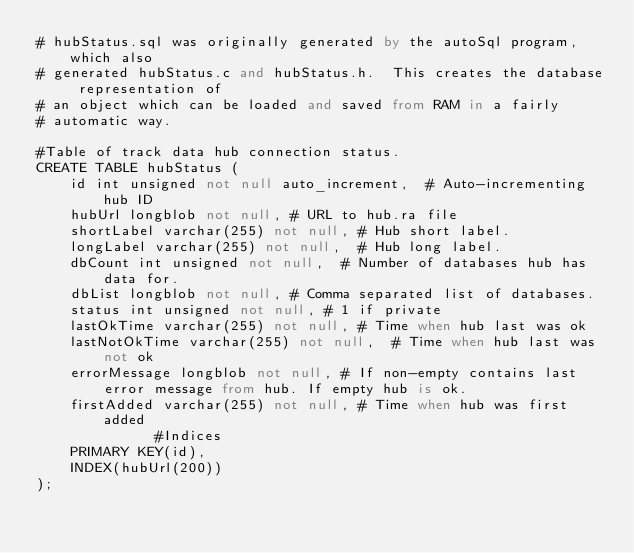<code> <loc_0><loc_0><loc_500><loc_500><_SQL_># hubStatus.sql was originally generated by the autoSql program, which also 
# generated hubStatus.c and hubStatus.h.  This creates the database representation of
# an object which can be loaded and saved from RAM in a fairly 
# automatic way.

#Table of track data hub connection status.
CREATE TABLE hubStatus (
    id int unsigned not null auto_increment,	# Auto-incrementing hub ID
    hubUrl longblob not null,	# URL to hub.ra file
    shortLabel varchar(255) not null,	# Hub short label.
    longLabel varchar(255) not null,	# Hub long label.
    dbCount int unsigned not null,	# Number of databases hub has data for.
    dbList longblob not null,	# Comma separated list of databases.
    status int unsigned not null,	# 1 if private
    lastOkTime varchar(255) not null,	# Time when hub last was ok
    lastNotOkTime varchar(255) not null,	# Time when hub last was not ok
    errorMessage longblob not null,	# If non-empty contains last error message from hub. If empty hub is ok.
    firstAdded varchar(255) not null,	# Time when hub was first added
              #Indices
    PRIMARY KEY(id),
    INDEX(hubUrl(200))
);
</code> 